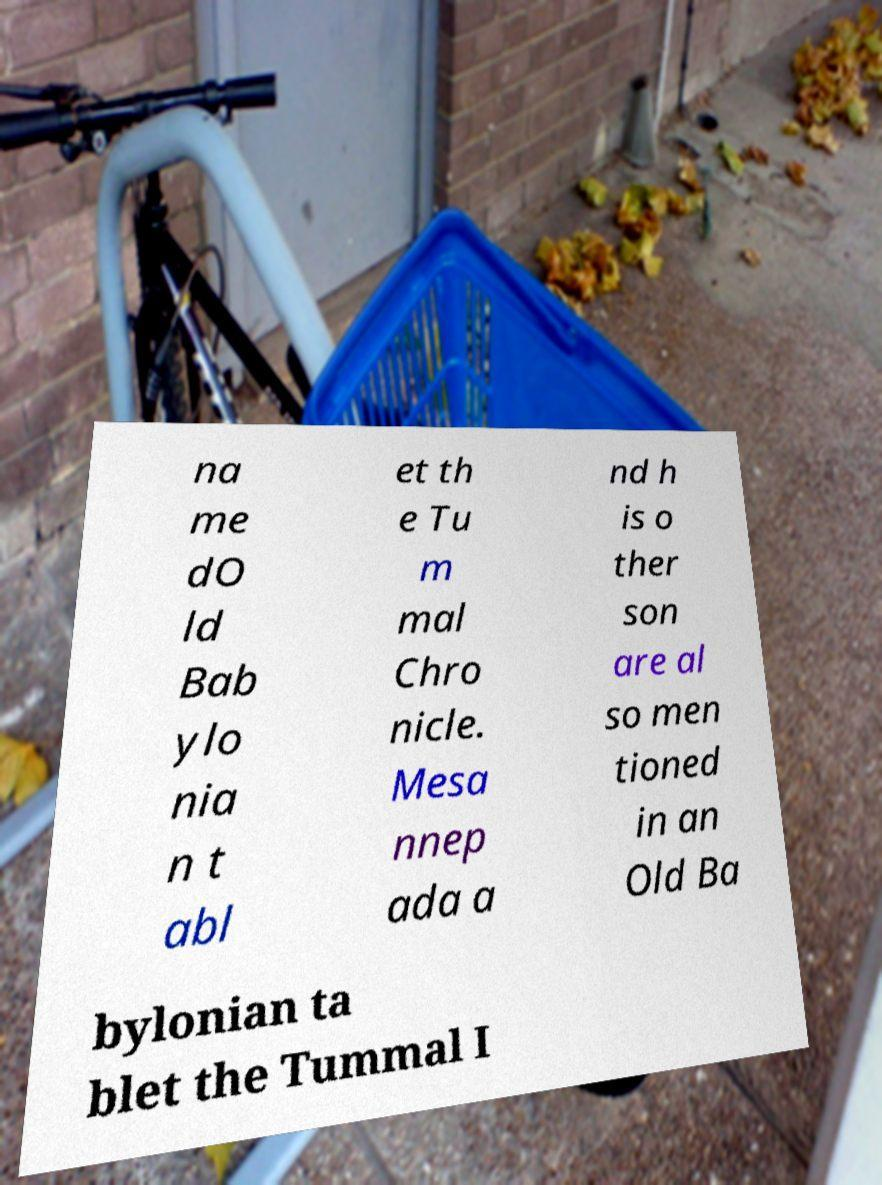There's text embedded in this image that I need extracted. Can you transcribe it verbatim? na me dO ld Bab ylo nia n t abl et th e Tu m mal Chro nicle. Mesa nnep ada a nd h is o ther son are al so men tioned in an Old Ba bylonian ta blet the Tummal I 